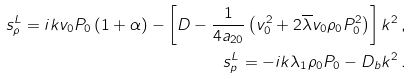Convert formula to latex. <formula><loc_0><loc_0><loc_500><loc_500>s _ { \rho } ^ { L } = i k v _ { 0 } P _ { 0 } \left ( 1 + \alpha \right ) - \left [ D - \frac { 1 } { 4 a _ { 2 0 } } \left ( v _ { 0 } ^ { 2 } + 2 \overline { \lambda } v _ { 0 } \rho _ { 0 } P _ { 0 } ^ { 2 } \right ) \right ] k ^ { 2 } \, , \\ s _ { p } ^ { L } = - i k \lambda _ { 1 } \rho _ { 0 } P _ { 0 } - D _ { b } k ^ { 2 } \, .</formula> 